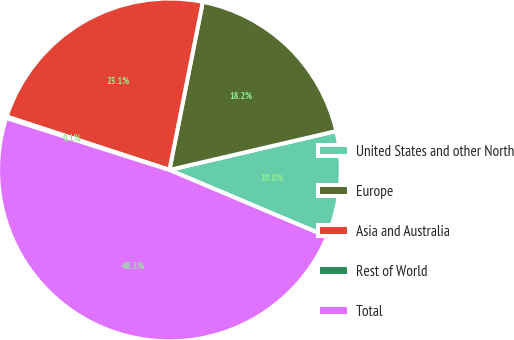Convert chart to OTSL. <chart><loc_0><loc_0><loc_500><loc_500><pie_chart><fcel>United States and other North<fcel>Europe<fcel>Asia and Australia<fcel>Rest of World<fcel>Total<nl><fcel>10.01%<fcel>18.24%<fcel>23.08%<fcel>0.14%<fcel>48.54%<nl></chart> 